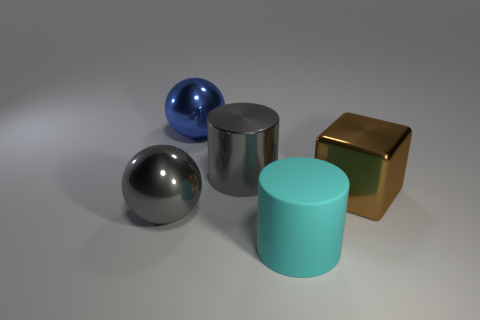Subtract all gray cylinders. How many cylinders are left? 1 Add 2 cyan matte cylinders. How many objects exist? 7 Subtract 1 cylinders. How many cylinders are left? 1 Subtract all spheres. How many objects are left? 3 Add 5 large cyan matte objects. How many large cyan matte objects exist? 6 Subtract 0 yellow cylinders. How many objects are left? 5 Subtract all brown cylinders. Subtract all purple blocks. How many cylinders are left? 2 Subtract all blue balls. How many cyan cylinders are left? 1 Subtract all large metallic cylinders. Subtract all big cubes. How many objects are left? 3 Add 3 large brown blocks. How many large brown blocks are left? 4 